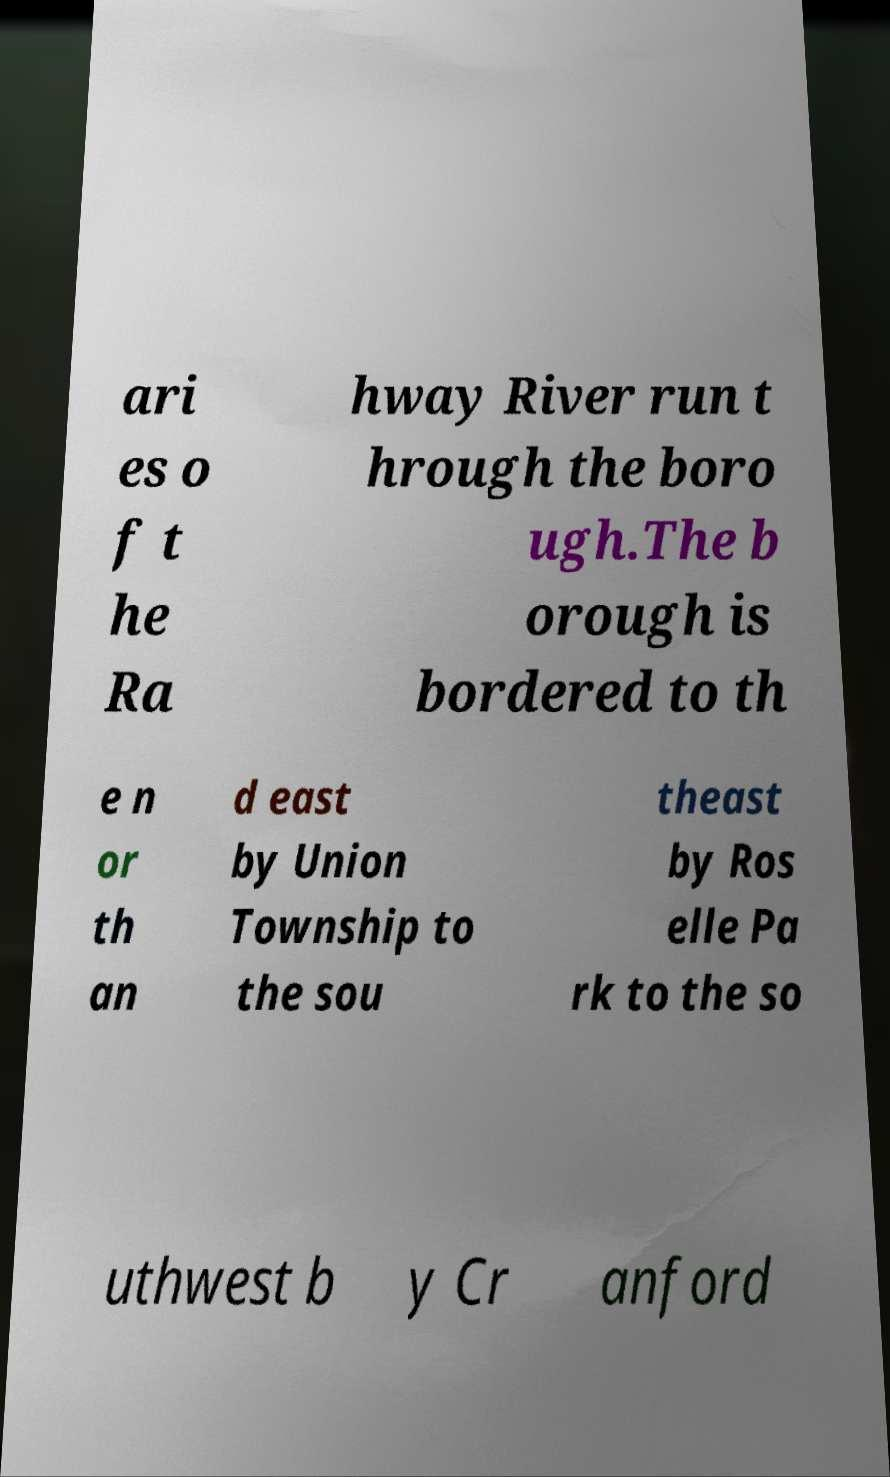Can you accurately transcribe the text from the provided image for me? ari es o f t he Ra hway River run t hrough the boro ugh.The b orough is bordered to th e n or th an d east by Union Township to the sou theast by Ros elle Pa rk to the so uthwest b y Cr anford 